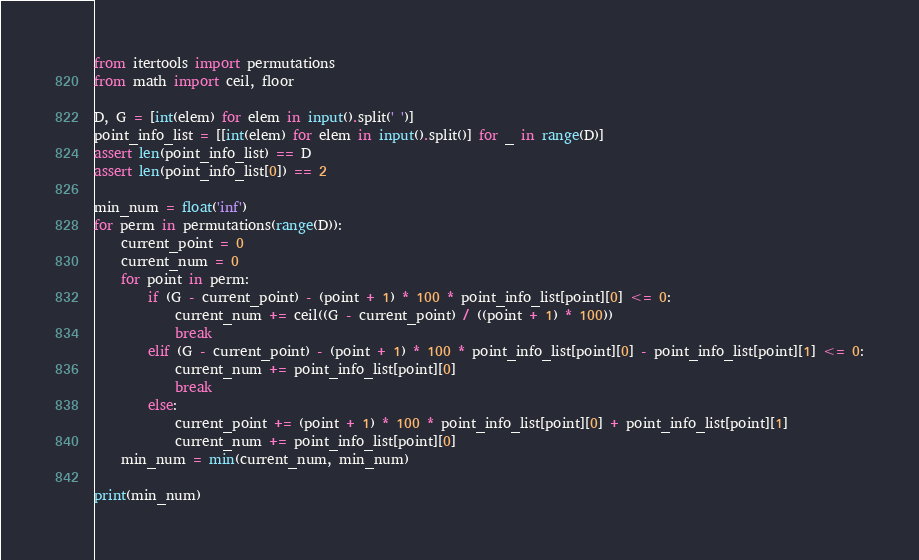Convert code to text. <code><loc_0><loc_0><loc_500><loc_500><_Python_>from itertools import permutations
from math import ceil, floor

D, G = [int(elem) for elem in input().split(' ')]
point_info_list = [[int(elem) for elem in input().split()] for _ in range(D)]
assert len(point_info_list) == D
assert len(point_info_list[0]) == 2

min_num = float('inf')
for perm in permutations(range(D)):
    current_point = 0
    current_num = 0
    for point in perm:
        if (G - current_point) - (point + 1) * 100 * point_info_list[point][0] <= 0:
            current_num += ceil((G - current_point) / ((point + 1) * 100))
            break
        elif (G - current_point) - (point + 1) * 100 * point_info_list[point][0] - point_info_list[point][1] <= 0:
            current_num += point_info_list[point][0]
            break
        else:
            current_point += (point + 1) * 100 * point_info_list[point][0] + point_info_list[point][1]
            current_num += point_info_list[point][0]
    min_num = min(current_num, min_num)

print(min_num)

</code> 